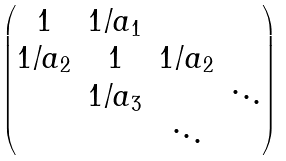Convert formula to latex. <formula><loc_0><loc_0><loc_500><loc_500>\begin{pmatrix} 1 & 1 / a _ { 1 } & & \\ 1 / a _ { 2 } & 1 & 1 / a _ { 2 } & \\ & 1 / a _ { 3 } & & \ddots \\ & & \ddots & \end{pmatrix}</formula> 